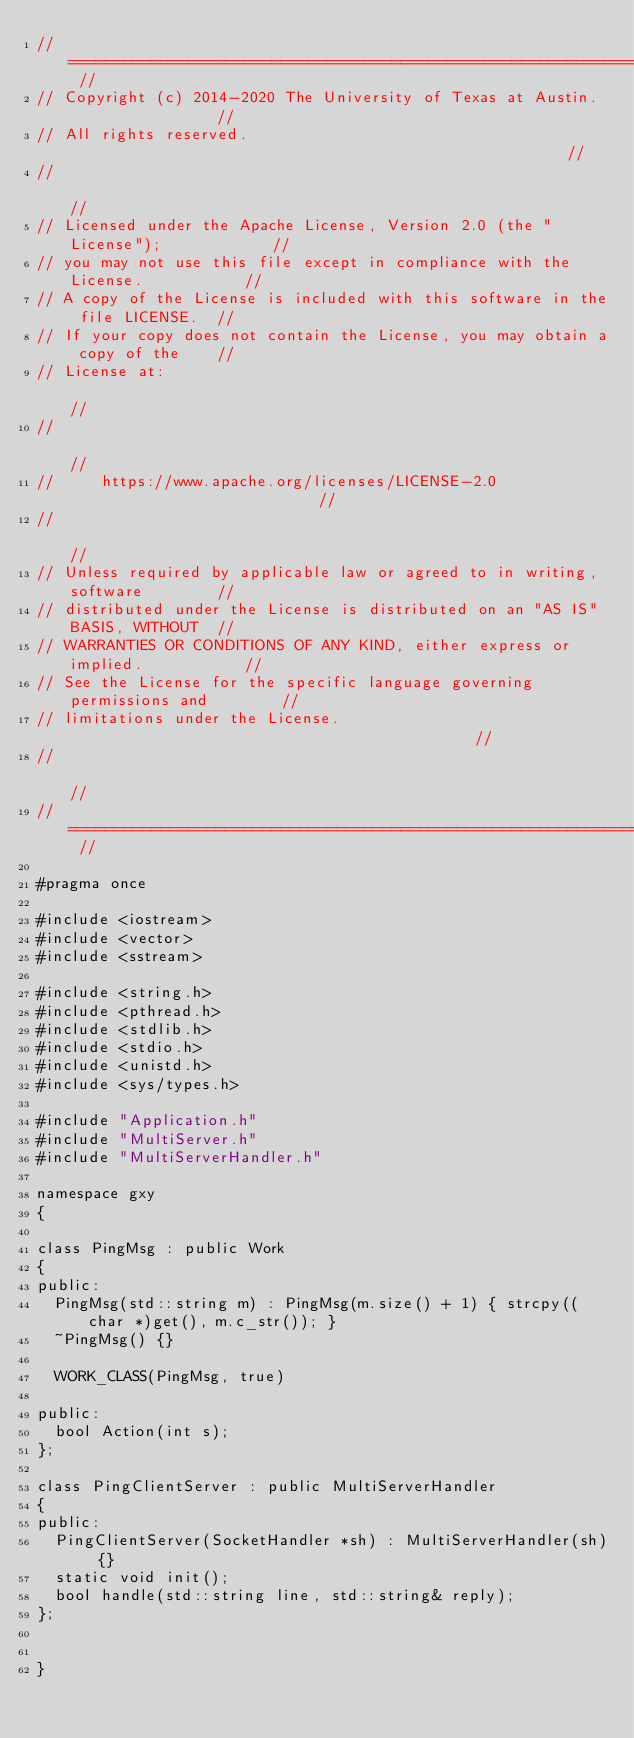Convert code to text. <code><loc_0><loc_0><loc_500><loc_500><_C_>// ========================================================================== //
// Copyright (c) 2014-2020 The University of Texas at Austin.                 //
// All rights reserved.                                                       //
//                                                                            //
// Licensed under the Apache License, Version 2.0 (the "License");            //
// you may not use this file except in compliance with the License.           //
// A copy of the License is included with this software in the file LICENSE.  //
// If your copy does not contain the License, you may obtain a copy of the    //
// License at:                                                                //
//                                                                            //
//     https://www.apache.org/licenses/LICENSE-2.0                            //
//                                                                            //
// Unless required by applicable law or agreed to in writing, software        //
// distributed under the License is distributed on an "AS IS" BASIS, WITHOUT  //
// WARRANTIES OR CONDITIONS OF ANY KIND, either express or implied.           //
// See the License for the specific language governing permissions and        //
// limitations under the License.                                             //
//                                                                            //
// ========================================================================== //

#pragma once

#include <iostream>
#include <vector>
#include <sstream>

#include <string.h>
#include <pthread.h>
#include <stdlib.h>
#include <stdio.h>
#include <unistd.h>
#include <sys/types.h>

#include "Application.h"
#include "MultiServer.h"
#include "MultiServerHandler.h"

namespace gxy
{

class PingMsg : public Work
{
public:
  PingMsg(std::string m) : PingMsg(m.size() + 1) { strcpy((char *)get(), m.c_str()); }
  ~PingMsg() {}

  WORK_CLASS(PingMsg, true)

public:
  bool Action(int s);
};

class PingClientServer : public MultiServerHandler
{
public:
  PingClientServer(SocketHandler *sh) : MultiServerHandler(sh) {}
  static void init();
  bool handle(std::string line, std::string& reply);
};


}
</code> 